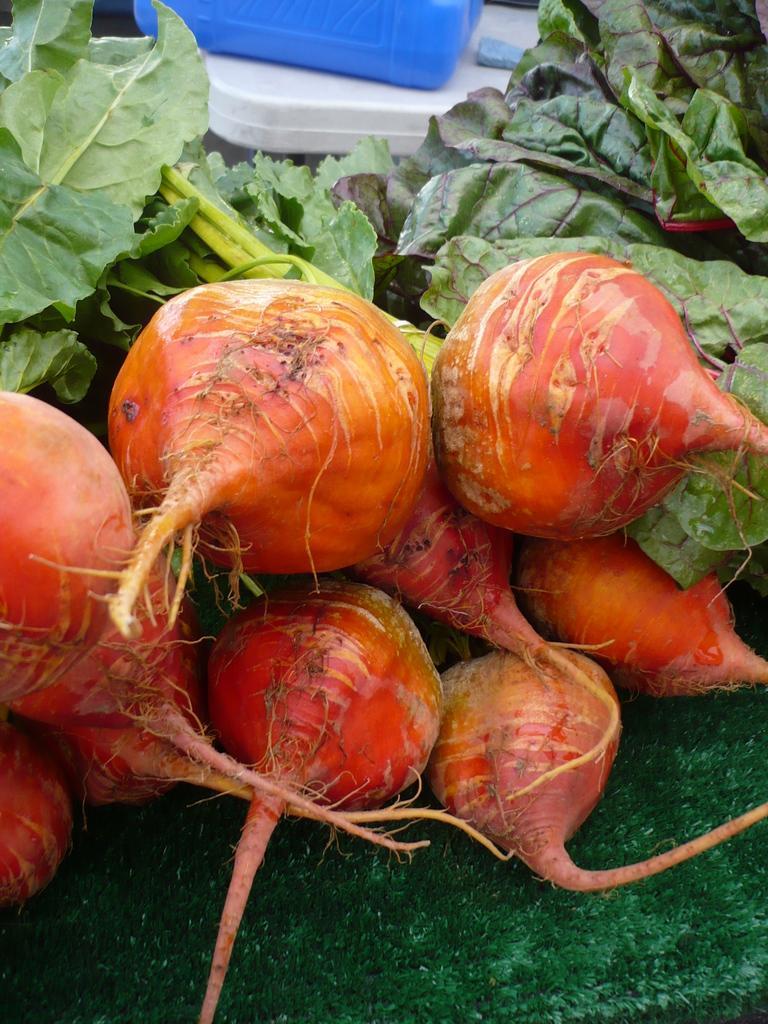Please provide a concise description of this image. In this picture, it seems like beetroots in the foreground area of the image and some objects in the background. 